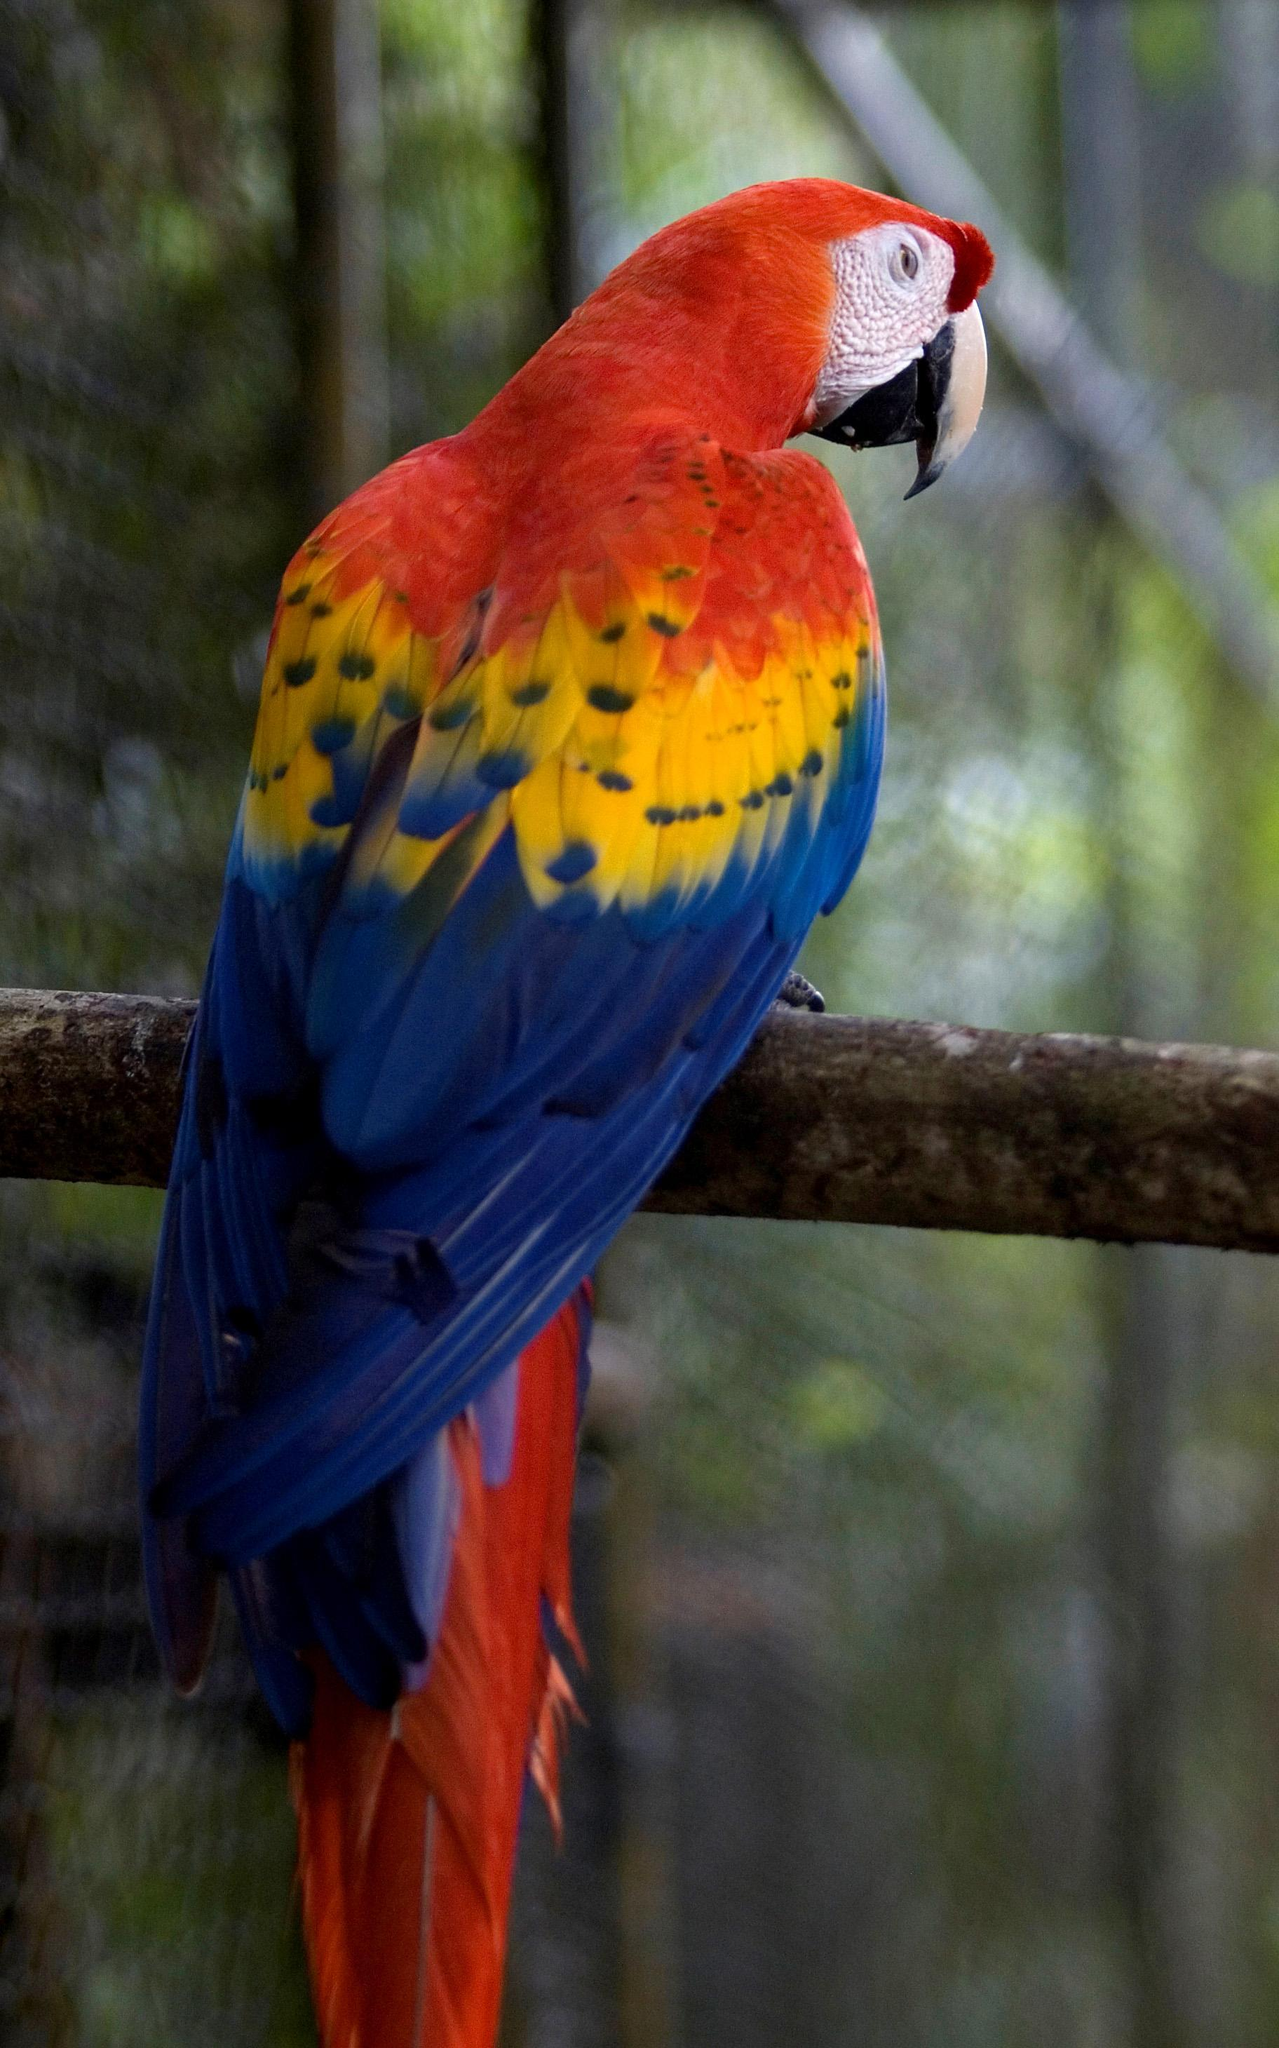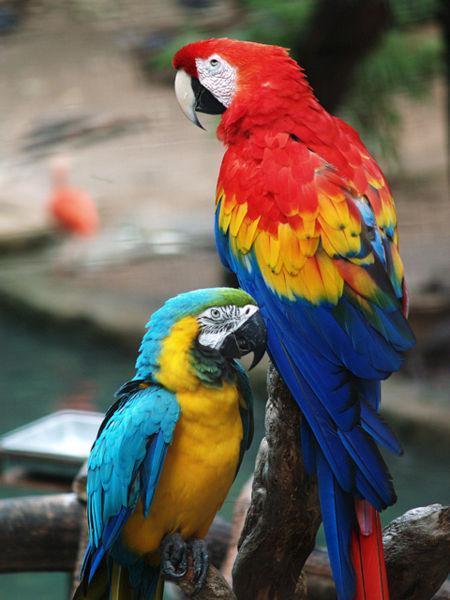The first image is the image on the left, the second image is the image on the right. Examine the images to the left and right. Is the description "At least one image contains a macaw in flight." accurate? Answer yes or no. No. 